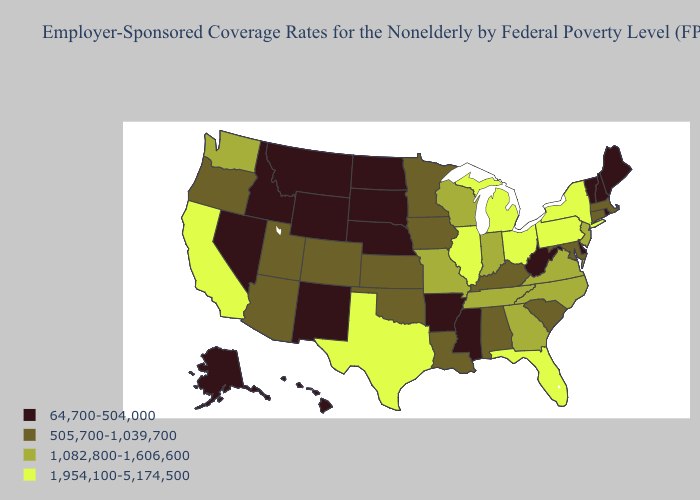Among the states that border Idaho , which have the highest value?
Give a very brief answer. Washington. Does Maine have the highest value in the Northeast?
Give a very brief answer. No. What is the lowest value in the West?
Answer briefly. 64,700-504,000. What is the value of Arkansas?
Give a very brief answer. 64,700-504,000. What is the value of Rhode Island?
Be succinct. 64,700-504,000. What is the value of Arizona?
Concise answer only. 505,700-1,039,700. Name the states that have a value in the range 1,082,800-1,606,600?
Give a very brief answer. Georgia, Indiana, Missouri, New Jersey, North Carolina, Tennessee, Virginia, Washington, Wisconsin. Among the states that border Massachusetts , does New York have the highest value?
Write a very short answer. Yes. Does the first symbol in the legend represent the smallest category?
Answer briefly. Yes. Is the legend a continuous bar?
Keep it brief. No. Among the states that border Wyoming , which have the lowest value?
Quick response, please. Idaho, Montana, Nebraska, South Dakota. Name the states that have a value in the range 1,082,800-1,606,600?
Be succinct. Georgia, Indiana, Missouri, New Jersey, North Carolina, Tennessee, Virginia, Washington, Wisconsin. Among the states that border Louisiana , does Mississippi have the highest value?
Concise answer only. No. Does Pennsylvania have a higher value than New York?
Quick response, please. No. What is the value of Illinois?
Give a very brief answer. 1,954,100-5,174,500. 